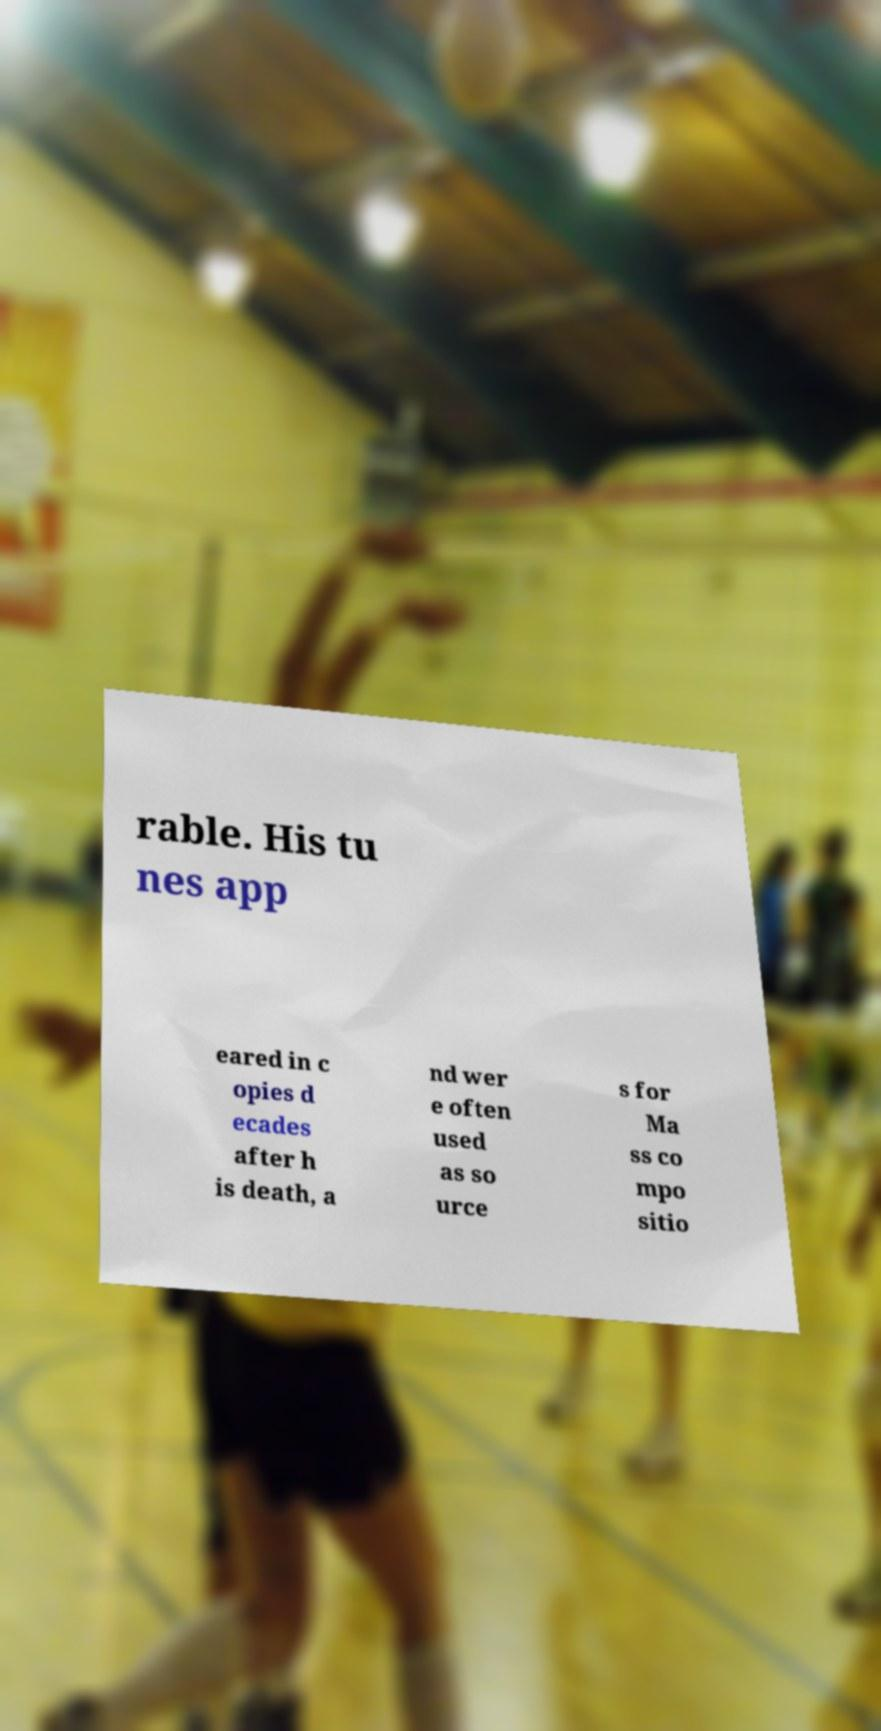Please read and relay the text visible in this image. What does it say? rable. His tu nes app eared in c opies d ecades after h is death, a nd wer e often used as so urce s for Ma ss co mpo sitio 